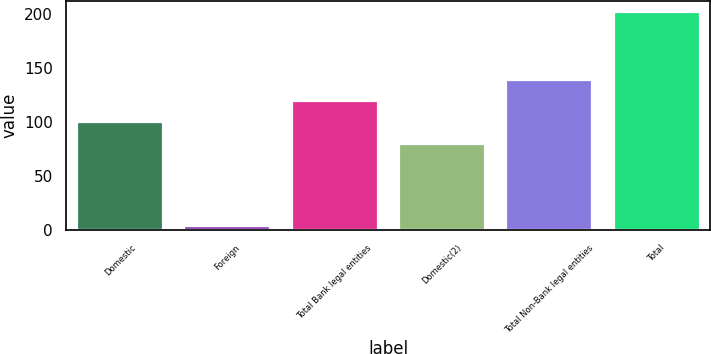<chart> <loc_0><loc_0><loc_500><loc_500><bar_chart><fcel>Domestic<fcel>Foreign<fcel>Total Bank legal entities<fcel>Domestic(2)<fcel>Total Non-Bank legal entities<fcel>Total<nl><fcel>99.8<fcel>4<fcel>119.6<fcel>80<fcel>139.4<fcel>202<nl></chart> 